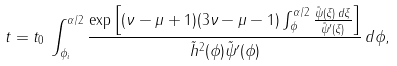<formula> <loc_0><loc_0><loc_500><loc_500>t = t _ { 0 } \, \int _ { \phi _ { i } } ^ { \alpha / 2 } \frac { \exp \left [ ( \nu - \mu + 1 ) ( 3 \nu - \mu - 1 ) \int _ { \phi } ^ { \alpha / 2 } \frac { \tilde { \psi } ( \xi ) \, d \xi } { \tilde { \psi } ^ { \prime } ( \xi ) } \right ] } { \tilde { h } ^ { 2 } ( \phi ) \tilde { \psi } ^ { \prime } ( \phi ) } \, d \phi ,</formula> 